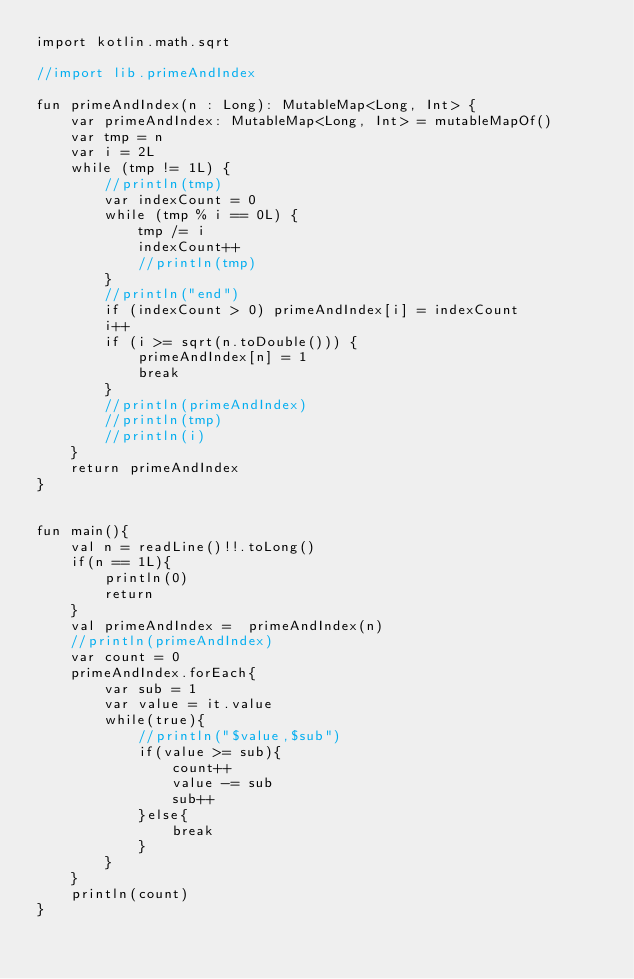<code> <loc_0><loc_0><loc_500><loc_500><_Kotlin_>import kotlin.math.sqrt

//import lib.primeAndIndex

fun primeAndIndex(n : Long): MutableMap<Long, Int> {
    var primeAndIndex: MutableMap<Long, Int> = mutableMapOf()
    var tmp = n
    var i = 2L
    while (tmp != 1L) {
        //println(tmp)
        var indexCount = 0
        while (tmp % i == 0L) {
            tmp /= i
            indexCount++
            //println(tmp)
        }
        //println("end")
        if (indexCount > 0) primeAndIndex[i] = indexCount
        i++
        if (i >= sqrt(n.toDouble())) {
            primeAndIndex[n] = 1
            break
        }
        //println(primeAndIndex)
        //println(tmp)
        //println(i)
    }
    return primeAndIndex
}


fun main(){
    val n = readLine()!!.toLong()
    if(n == 1L){
        println(0)
        return
    }
    val primeAndIndex =  primeAndIndex(n)
    //println(primeAndIndex)
    var count = 0
    primeAndIndex.forEach{
        var sub = 1
        var value = it.value
        while(true){
            //println("$value,$sub")
            if(value >= sub){
                count++
                value -= sub
                sub++
            }else{
                break
            }
        }
    }
    println(count)
}</code> 